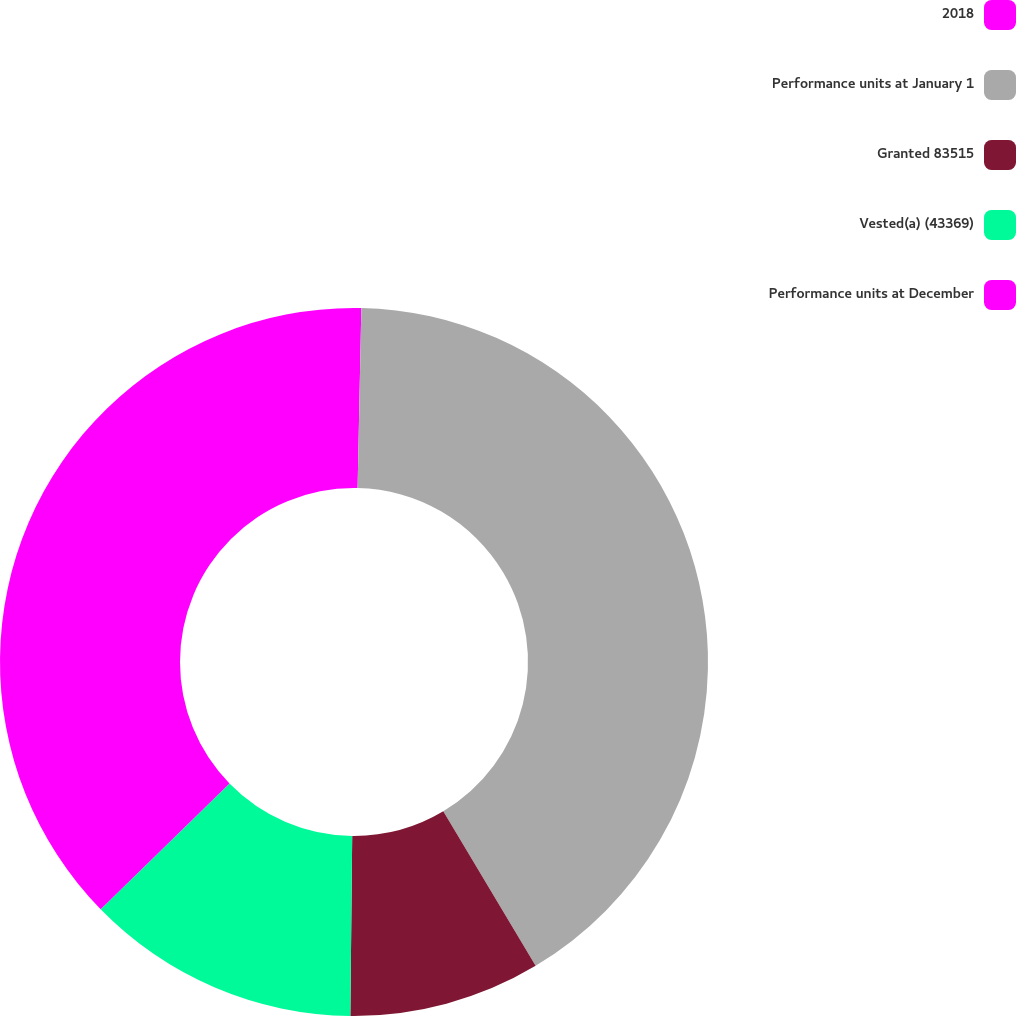Convert chart to OTSL. <chart><loc_0><loc_0><loc_500><loc_500><pie_chart><fcel>2018<fcel>Performance units at January 1<fcel>Granted 83515<fcel>Vested(a) (43369)<fcel>Performance units at December<nl><fcel>0.33%<fcel>41.1%<fcel>8.74%<fcel>12.53%<fcel>37.31%<nl></chart> 